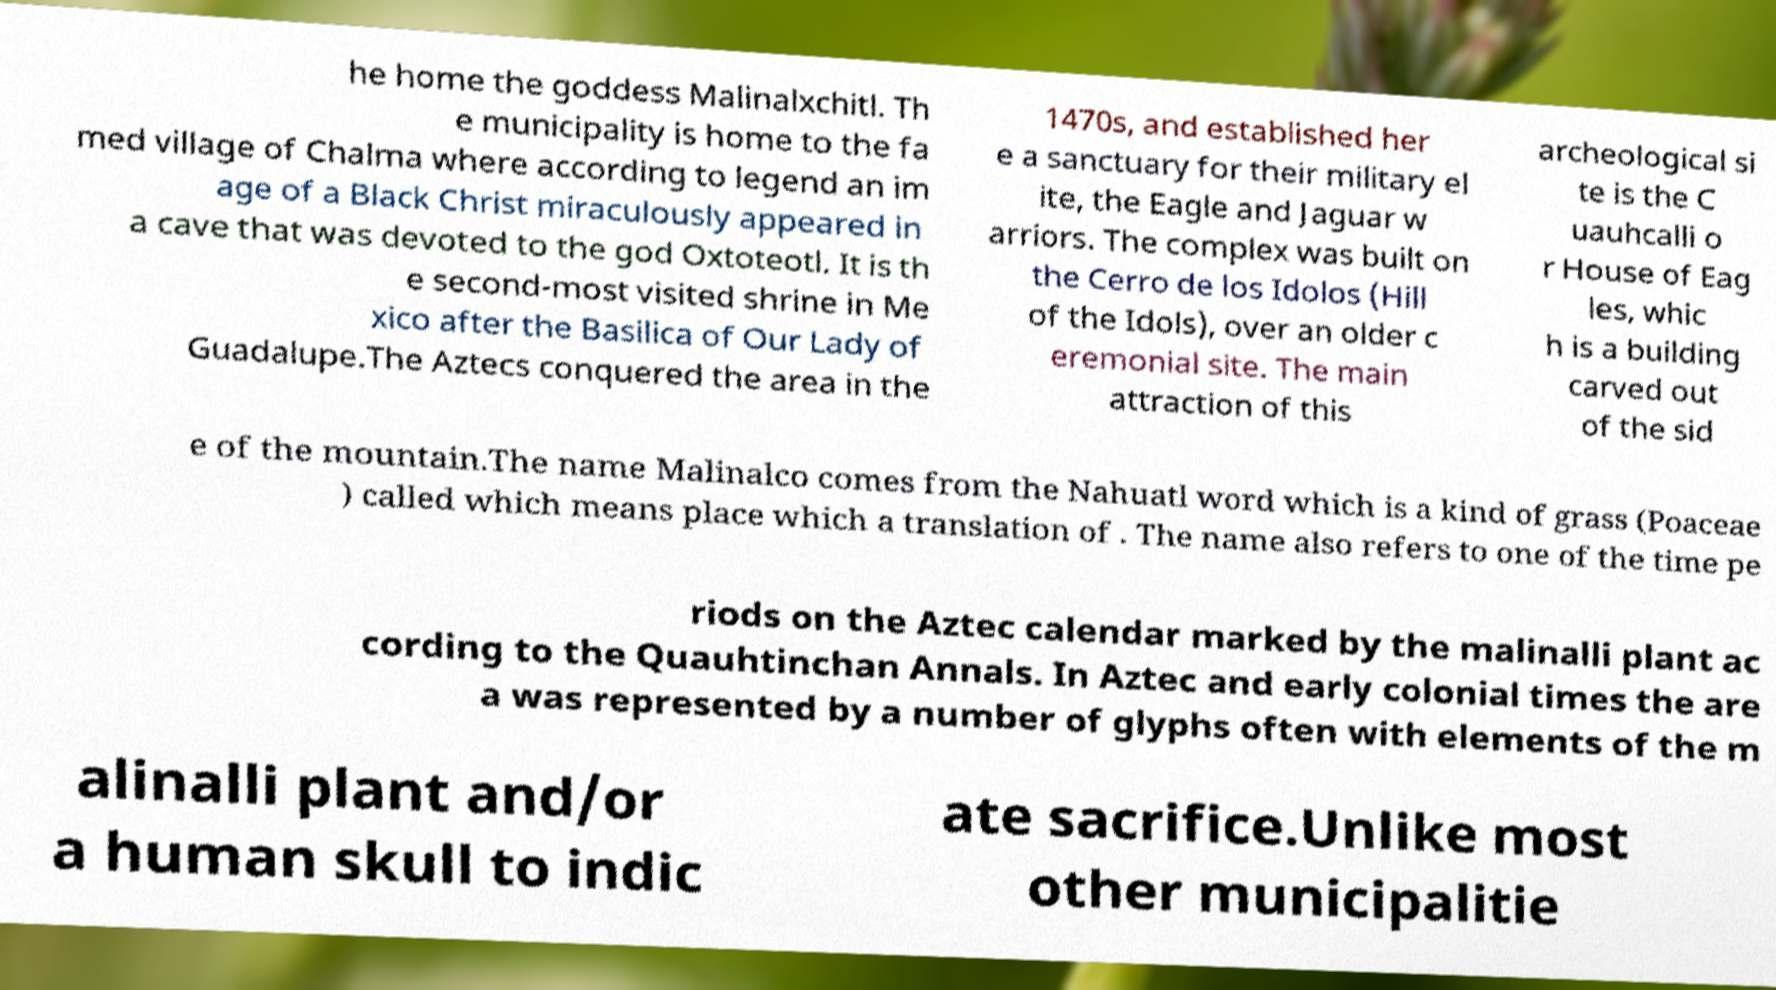Please identify and transcribe the text found in this image. he home the goddess Malinalxchitl. Th e municipality is home to the fa med village of Chalma where according to legend an im age of a Black Christ miraculously appeared in a cave that was devoted to the god Oxtoteotl. It is th e second-most visited shrine in Me xico after the Basilica of Our Lady of Guadalupe.The Aztecs conquered the area in the 1470s, and established her e a sanctuary for their military el ite, the Eagle and Jaguar w arriors. The complex was built on the Cerro de los Idolos (Hill of the Idols), over an older c eremonial site. The main attraction of this archeological si te is the C uauhcalli o r House of Eag les, whic h is a building carved out of the sid e of the mountain.The name Malinalco comes from the Nahuatl word which is a kind of grass (Poaceae ) called which means place which a translation of . The name also refers to one of the time pe riods on the Aztec calendar marked by the malinalli plant ac cording to the Quauhtinchan Annals. In Aztec and early colonial times the are a was represented by a number of glyphs often with elements of the m alinalli plant and/or a human skull to indic ate sacrifice.Unlike most other municipalitie 